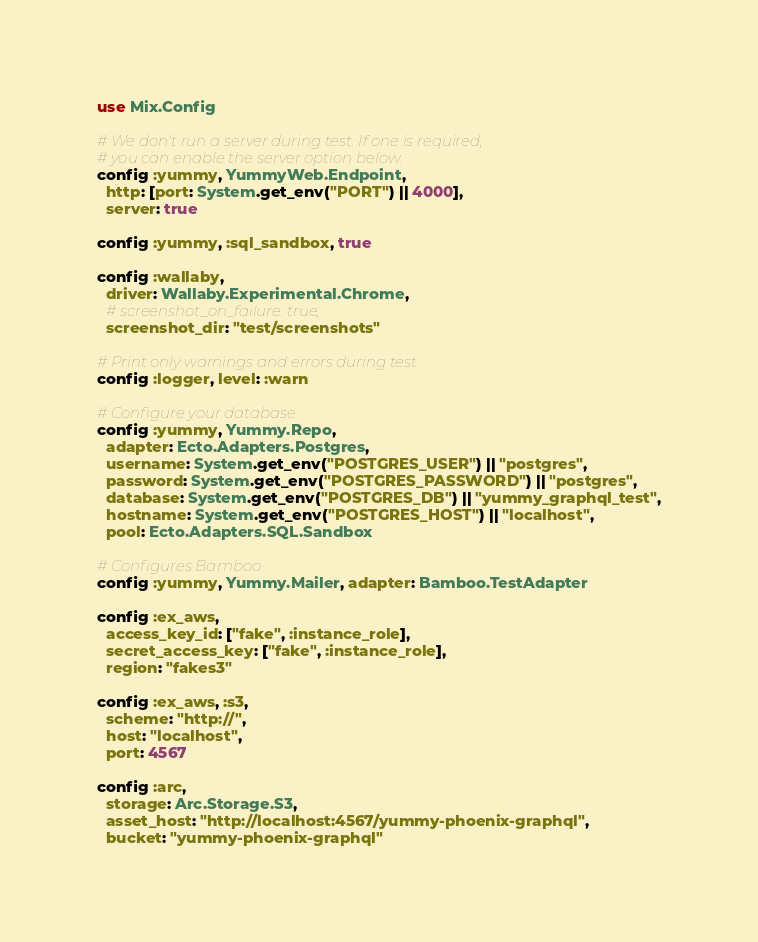<code> <loc_0><loc_0><loc_500><loc_500><_Elixir_>use Mix.Config

# We don't run a server during test. If one is required,
# you can enable the server option below.
config :yummy, YummyWeb.Endpoint,
  http: [port: System.get_env("PORT") || 4000],
  server: true

config :yummy, :sql_sandbox, true

config :wallaby,
  driver: Wallaby.Experimental.Chrome,
  # screenshot_on_failure: true,
  screenshot_dir: "test/screenshots"

# Print only warnings and errors during test
config :logger, level: :warn

# Configure your database
config :yummy, Yummy.Repo,
  adapter: Ecto.Adapters.Postgres,
  username: System.get_env("POSTGRES_USER") || "postgres",
  password: System.get_env("POSTGRES_PASSWORD") || "postgres",
  database: System.get_env("POSTGRES_DB") || "yummy_graphql_test",
  hostname: System.get_env("POSTGRES_HOST") || "localhost",
  pool: Ecto.Adapters.SQL.Sandbox

# Configures Bamboo
config :yummy, Yummy.Mailer, adapter: Bamboo.TestAdapter

config :ex_aws,
  access_key_id: ["fake", :instance_role],
  secret_access_key: ["fake", :instance_role],
  region: "fakes3"

config :ex_aws, :s3,
  scheme: "http://",
  host: "localhost",
  port: 4567

config :arc,
  storage: Arc.Storage.S3,
  asset_host: "http://localhost:4567/yummy-phoenix-graphql",
  bucket: "yummy-phoenix-graphql"
</code> 